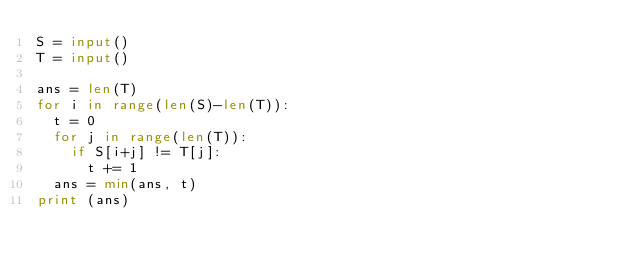<code> <loc_0><loc_0><loc_500><loc_500><_Python_>S = input()
T = input()

ans = len(T)
for i in range(len(S)-len(T)):
  t = 0
  for j in range(len(T)):
    if S[i+j] != T[j]:
      t += 1
  ans = min(ans, t)
print (ans)</code> 